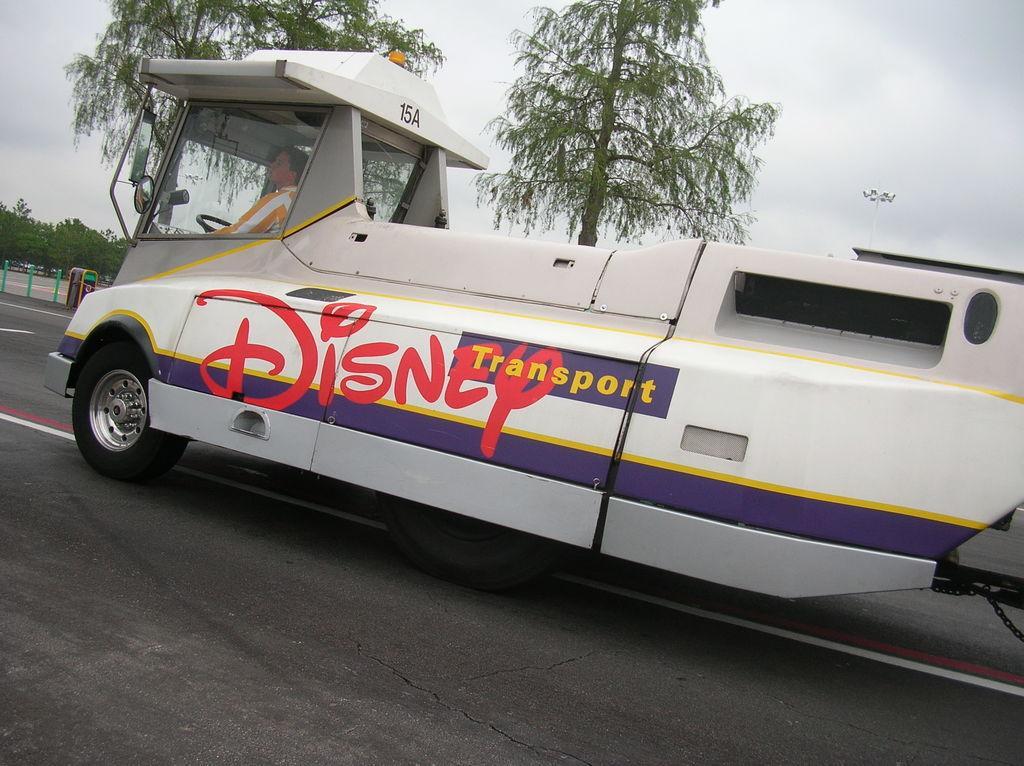Please provide a concise description of this image. In this image we can see a vehicle on the road and there is a person sitting in the vehicle. In the background there are trees and sky. At the bottom there is a road. 